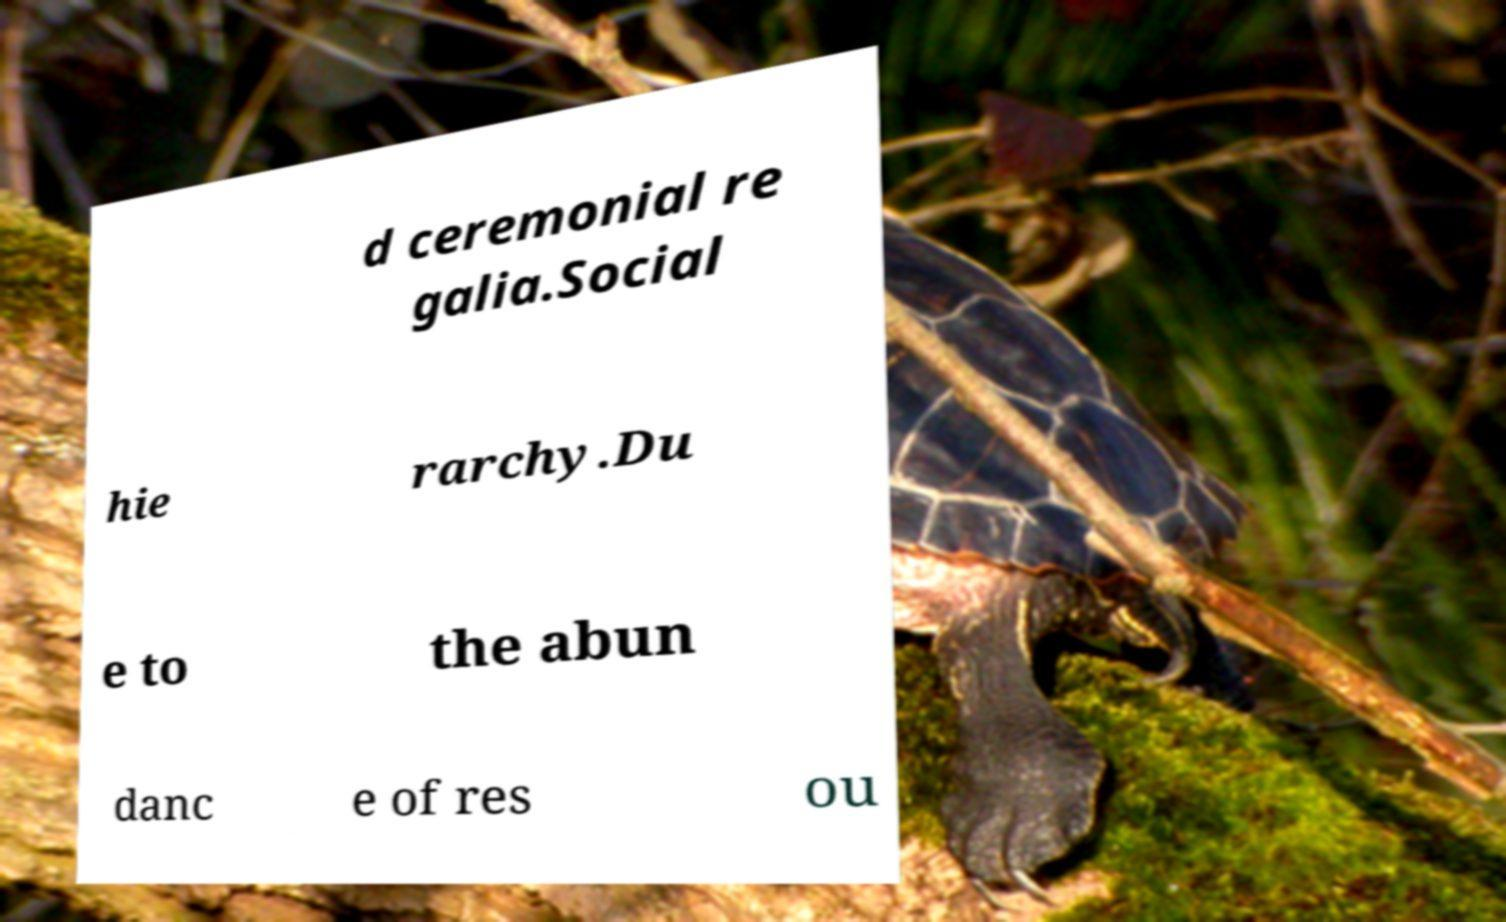Could you extract and type out the text from this image? d ceremonial re galia.Social hie rarchy.Du e to the abun danc e of res ou 